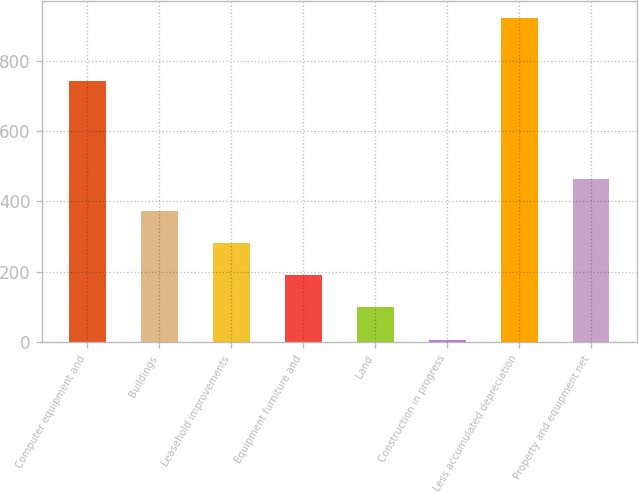Convert chart. <chart><loc_0><loc_0><loc_500><loc_500><bar_chart><fcel>Computer equipment and<fcel>Buildings<fcel>Leasehold improvements<fcel>Equipment furniture and<fcel>Land<fcel>Construction in progress<fcel>Less accumulated depreciation<fcel>Property and equipment net<nl><fcel>744<fcel>373.4<fcel>281.8<fcel>190.2<fcel>98.6<fcel>7<fcel>923<fcel>465<nl></chart> 